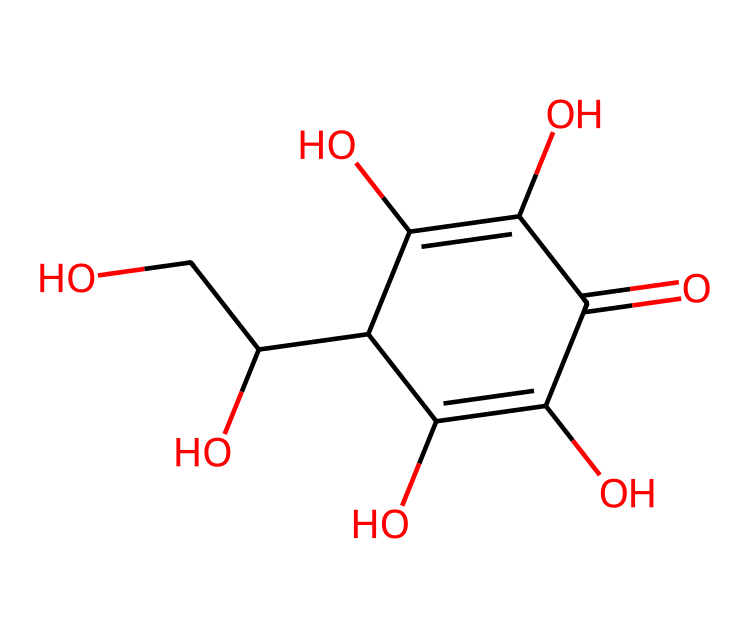What is the name of this chemical? The SMILES representation corresponds to a well-known antioxidant, as it reflects the molecular structure of ascorbic acid, commonly known as vitamin C.
Answer: vitamin C How many carbon atoms are there in this structure? By analyzing the SMILES representation, we can identify the carbon atoms present. There are 6 carbon atoms in the structure of vitamin C.
Answer: 6 What is the functional group present in this antioxidant? The presence of hydroxyl (-OH) groups can be identified through the SMILES representation, indicating that vitamin C contains multiple alcohol functional groups.
Answer: hydroxyl How many double bonds are present in the structure? By examining the connections in the SMILES line notation, it is evident that there are 2 double bonds in the structure of vitamin C.
Answer: 2 What type of chemical is vitamin C categorized as? Given that vitamin C acts as an antioxidant and has multiple hydroxyl groups, it falls into the category of water-soluble vitamins, specifically classified as a vitamin.
Answer: vitamin How many oxygen atoms does vitamin C have? In the SMILES notation, the oxygen atoms can be counted. There are 4 oxygen atoms present in the vitamin C molecule.
Answer: 4 What property of vitamin C allows it to act as an antioxidant? The presence of hydroxyl groups contributes to the reactivity of vitamin C, allowing it to donate electrons and neutralize free radicals.
Answer: electron donor 